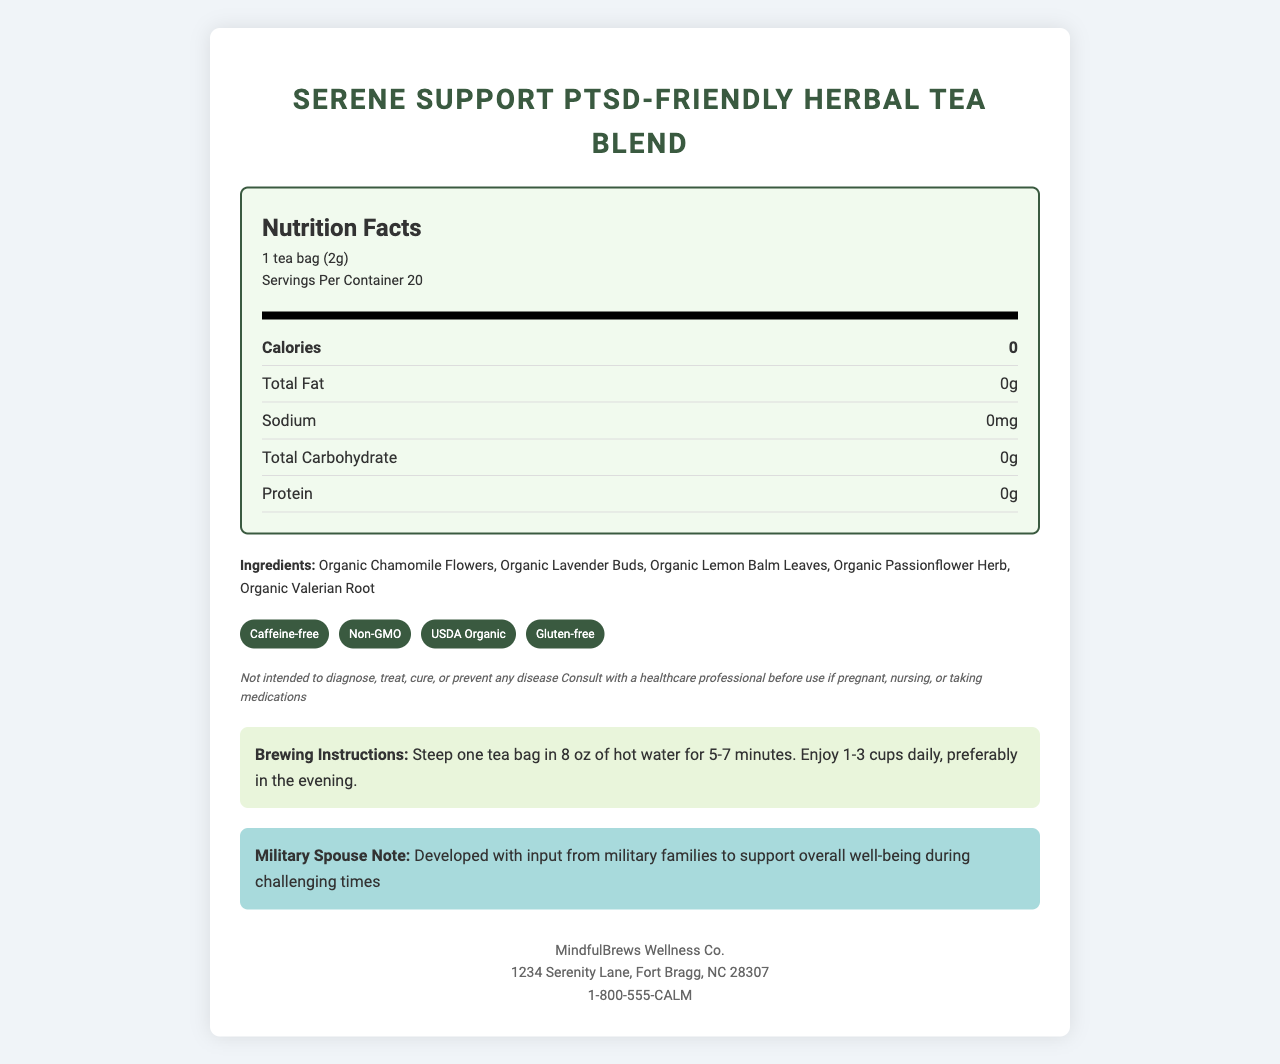what is the serving size? The serving size is mentioned at the top of the Nutrition Facts section.
Answer: 1 tea bag (2g) how many servings are there per container? The number of servings per container is mentioned below the serving size.
Answer: 20 how many calories are there per serving? The calories per serving are listed in the Nutrition Facts section.
Answer: 0 name two key ingredients in this tea blend. These are mentioned as the first two ingredients in the ingredients list.
Answer: Organic Chamomile Flowers and Organic Lavender Buds is the tea caffeine-free? "Caffeine-free" is listed under the special features section.
Answer: Yes which of the following is NOT listed as an ingredient? A. Organic Chamomile Flowers B. Organic Honey C. Organic Valerian Root D. Organic Lavender Buds Organic Honey is not listed in the ingredients; all other options are.
Answer: B how much total fat is in each serving? A. 0g B. 2g C. 1g D. 5g The total fat per serving is stated as 0g.
Answer: A is the product gluten-free? "Gluten-free" is listed under the special features section.
Answer: Yes are there any allergies warnings on the label? The label mentions that it's processed in a facility that also handles tree nuts and soy.
Answer: Yes who manufactures the Serene Support PTSD-Friendly Herbal Tea Blend? The manufacturer's information is listed at the bottom of the document.
Answer: MindfulBrews Wellness Co. where should you store the tea? The storage instructions clearly state this.
Answer: In a cool, dry place away from direct sunlight does the label include any disclaimers? The label includes disclaimers that it is not intended to diagnose, treat, cure, or prevent any disease, and to consult with a healthcare professional if pregnant, nursing, or taking medications.
Answer: Yes what is the purpose of the donations from the proceeds? The document mentions that part of the proceeds is donated to the National Center for PTSD.
Answer: Donations are made to the National Center for PTSD how should the tea be brewed? The brewing instructions provide this detailed process.
Answer: Steep one tea bag in 8 oz of hot water for 5-7 minutes. Enjoy 1-3 cups daily, preferably in the evening. who is this product developed with input from? The document mentions it was developed with input from military families to support overall well-being during challenging times.
Answer: Military families what benefits does the tea provide according to the label? The additional benefits section lists these three benefits.
Answer: May promote relaxation, can support better sleep quality, and helps in stress management is this product vetted by any organizations? "PTSD Alliance Approved" is listed under certifications, indicating vetting by an organization.
Answer: Yes summarize the main idea of the document. The document provides comprehensive information about the tea blend, its ingredients, nutritional facts, special features, brewing instructions, storage instructions, manufacturer details, and the purpose of the product.
Answer: The Serene Support PTSD-Friendly Herbal Tea Blend is a caffeine-free, organic tea made with calming ingredients like chamomile and lavender. It is designed to support individuals with PTSD, particularly military families, and aims to promote relaxation, improve sleep quality, and help manage stress. The tea is produced by MindfulBrews Wellness Co., and part of the proceeds are donated to the National Center for PTSD. what is the vitamin C content in this tea? The document does not provide information on the vitamin C content.
Answer: Cannot be determined 